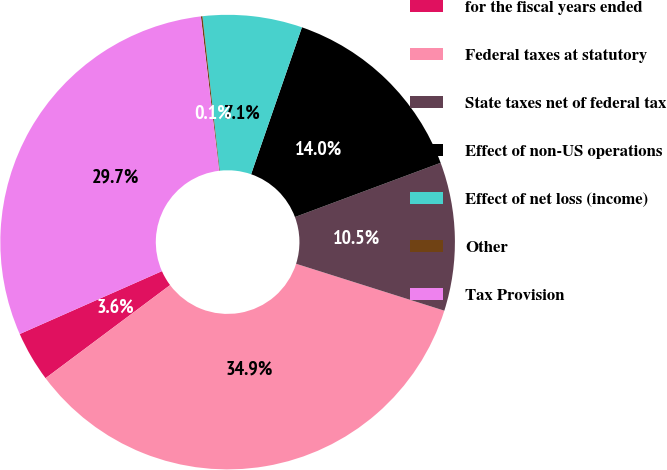Convert chart. <chart><loc_0><loc_0><loc_500><loc_500><pie_chart><fcel>for the fiscal years ended<fcel>Federal taxes at statutory<fcel>State taxes net of federal tax<fcel>Effect of non-US operations<fcel>Effect of net loss (income)<fcel>Other<fcel>Tax Provision<nl><fcel>3.59%<fcel>34.91%<fcel>10.55%<fcel>14.03%<fcel>7.07%<fcel>0.11%<fcel>29.75%<nl></chart> 